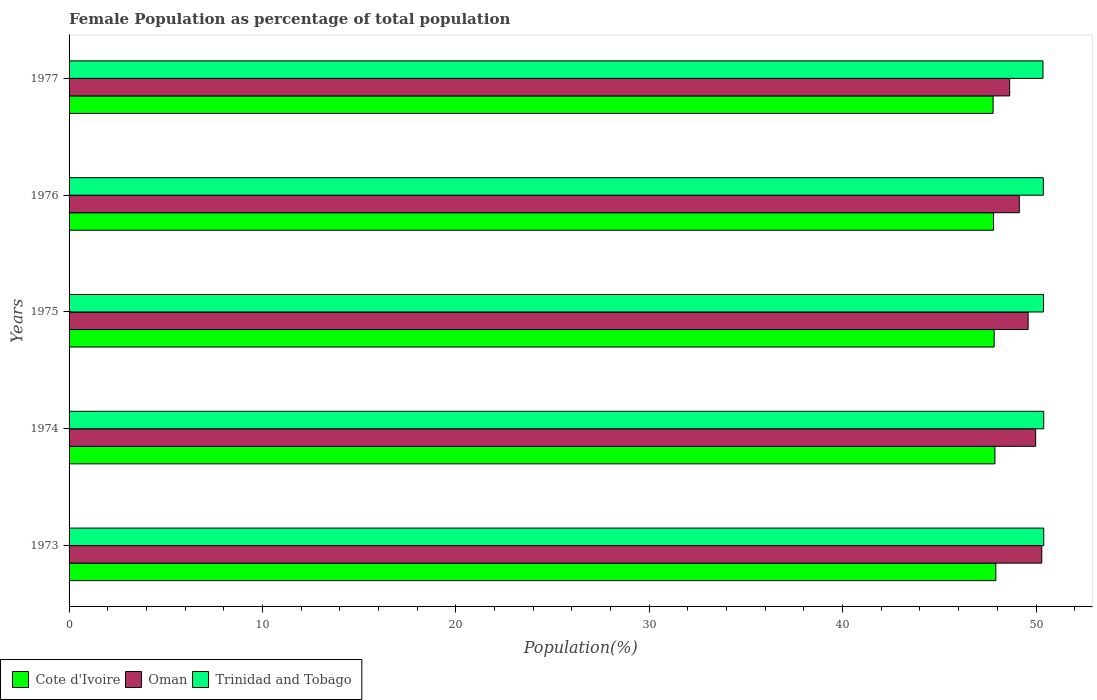How many groups of bars are there?
Offer a terse response. 5. How many bars are there on the 4th tick from the top?
Your response must be concise. 3. How many bars are there on the 2nd tick from the bottom?
Your answer should be very brief. 3. What is the label of the 2nd group of bars from the top?
Provide a succinct answer. 1976. What is the female population in in Trinidad and Tobago in 1975?
Give a very brief answer. 50.39. Across all years, what is the maximum female population in in Trinidad and Tobago?
Your answer should be compact. 50.4. Across all years, what is the minimum female population in in Cote d'Ivoire?
Your answer should be compact. 47.78. What is the total female population in in Trinidad and Tobago in the graph?
Ensure brevity in your answer.  251.93. What is the difference between the female population in in Trinidad and Tobago in 1974 and that in 1975?
Give a very brief answer. 0.01. What is the difference between the female population in in Trinidad and Tobago in 1977 and the female population in in Cote d'Ivoire in 1974?
Give a very brief answer. 2.48. What is the average female population in in Cote d'Ivoire per year?
Ensure brevity in your answer.  47.84. In the year 1974, what is the difference between the female population in in Trinidad and Tobago and female population in in Oman?
Your answer should be very brief. 0.42. In how many years, is the female population in in Oman greater than 10 %?
Keep it short and to the point. 5. What is the ratio of the female population in in Oman in 1974 to that in 1975?
Offer a very short reply. 1.01. Is the female population in in Cote d'Ivoire in 1973 less than that in 1974?
Offer a very short reply. No. What is the difference between the highest and the second highest female population in in Cote d'Ivoire?
Provide a short and direct response. 0.05. What is the difference between the highest and the lowest female population in in Oman?
Provide a short and direct response. 1.66. What does the 2nd bar from the top in 1974 represents?
Ensure brevity in your answer.  Oman. What does the 2nd bar from the bottom in 1976 represents?
Provide a succinct answer. Oman. Are all the bars in the graph horizontal?
Offer a terse response. Yes. Does the graph contain any zero values?
Ensure brevity in your answer.  No. How many legend labels are there?
Your response must be concise. 3. What is the title of the graph?
Ensure brevity in your answer.  Female Population as percentage of total population. What is the label or title of the X-axis?
Keep it short and to the point. Population(%). What is the label or title of the Y-axis?
Give a very brief answer. Years. What is the Population(%) in Cote d'Ivoire in 1973?
Make the answer very short. 47.92. What is the Population(%) in Oman in 1973?
Ensure brevity in your answer.  50.3. What is the Population(%) of Trinidad and Tobago in 1973?
Your answer should be compact. 50.4. What is the Population(%) of Cote d'Ivoire in 1974?
Provide a short and direct response. 47.88. What is the Population(%) of Oman in 1974?
Your answer should be very brief. 49.98. What is the Population(%) of Trinidad and Tobago in 1974?
Your answer should be very brief. 50.4. What is the Population(%) of Cote d'Ivoire in 1975?
Your answer should be compact. 47.84. What is the Population(%) in Oman in 1975?
Make the answer very short. 49.59. What is the Population(%) in Trinidad and Tobago in 1975?
Ensure brevity in your answer.  50.39. What is the Population(%) of Cote d'Ivoire in 1976?
Offer a very short reply. 47.81. What is the Population(%) of Oman in 1976?
Offer a very short reply. 49.14. What is the Population(%) of Trinidad and Tobago in 1976?
Provide a succinct answer. 50.38. What is the Population(%) in Cote d'Ivoire in 1977?
Offer a terse response. 47.78. What is the Population(%) of Oman in 1977?
Keep it short and to the point. 48.64. What is the Population(%) in Trinidad and Tobago in 1977?
Ensure brevity in your answer.  50.36. Across all years, what is the maximum Population(%) in Cote d'Ivoire?
Give a very brief answer. 47.92. Across all years, what is the maximum Population(%) in Oman?
Provide a succinct answer. 50.3. Across all years, what is the maximum Population(%) in Trinidad and Tobago?
Your response must be concise. 50.4. Across all years, what is the minimum Population(%) in Cote d'Ivoire?
Offer a very short reply. 47.78. Across all years, what is the minimum Population(%) in Oman?
Give a very brief answer. 48.64. Across all years, what is the minimum Population(%) in Trinidad and Tobago?
Your response must be concise. 50.36. What is the total Population(%) of Cote d'Ivoire in the graph?
Offer a very short reply. 239.22. What is the total Population(%) in Oman in the graph?
Ensure brevity in your answer.  247.65. What is the total Population(%) of Trinidad and Tobago in the graph?
Give a very brief answer. 251.93. What is the difference between the Population(%) of Cote d'Ivoire in 1973 and that in 1974?
Your answer should be very brief. 0.05. What is the difference between the Population(%) in Oman in 1973 and that in 1974?
Offer a terse response. 0.32. What is the difference between the Population(%) in Trinidad and Tobago in 1973 and that in 1974?
Offer a terse response. 0. What is the difference between the Population(%) in Cote d'Ivoire in 1973 and that in 1975?
Keep it short and to the point. 0.09. What is the difference between the Population(%) in Oman in 1973 and that in 1975?
Ensure brevity in your answer.  0.71. What is the difference between the Population(%) of Trinidad and Tobago in 1973 and that in 1975?
Ensure brevity in your answer.  0.01. What is the difference between the Population(%) in Cote d'Ivoire in 1973 and that in 1976?
Provide a succinct answer. 0.12. What is the difference between the Population(%) of Oman in 1973 and that in 1976?
Give a very brief answer. 1.16. What is the difference between the Population(%) in Trinidad and Tobago in 1973 and that in 1976?
Your answer should be very brief. 0.02. What is the difference between the Population(%) in Cote d'Ivoire in 1973 and that in 1977?
Offer a very short reply. 0.14. What is the difference between the Population(%) of Oman in 1973 and that in 1977?
Offer a very short reply. 1.66. What is the difference between the Population(%) in Trinidad and Tobago in 1973 and that in 1977?
Your answer should be compact. 0.04. What is the difference between the Population(%) of Cote d'Ivoire in 1974 and that in 1975?
Ensure brevity in your answer.  0.04. What is the difference between the Population(%) of Oman in 1974 and that in 1975?
Make the answer very short. 0.39. What is the difference between the Population(%) in Trinidad and Tobago in 1974 and that in 1975?
Ensure brevity in your answer.  0.01. What is the difference between the Population(%) of Cote d'Ivoire in 1974 and that in 1976?
Keep it short and to the point. 0.07. What is the difference between the Population(%) of Oman in 1974 and that in 1976?
Keep it short and to the point. 0.84. What is the difference between the Population(%) in Trinidad and Tobago in 1974 and that in 1976?
Offer a very short reply. 0.02. What is the difference between the Population(%) of Cote d'Ivoire in 1974 and that in 1977?
Offer a terse response. 0.1. What is the difference between the Population(%) in Oman in 1974 and that in 1977?
Your response must be concise. 1.34. What is the difference between the Population(%) in Trinidad and Tobago in 1974 and that in 1977?
Keep it short and to the point. 0.04. What is the difference between the Population(%) in Cote d'Ivoire in 1975 and that in 1976?
Offer a very short reply. 0.03. What is the difference between the Population(%) of Oman in 1975 and that in 1976?
Your answer should be very brief. 0.46. What is the difference between the Population(%) in Trinidad and Tobago in 1975 and that in 1976?
Ensure brevity in your answer.  0.01. What is the difference between the Population(%) in Cote d'Ivoire in 1975 and that in 1977?
Make the answer very short. 0.06. What is the difference between the Population(%) in Oman in 1975 and that in 1977?
Provide a short and direct response. 0.95. What is the difference between the Population(%) of Trinidad and Tobago in 1975 and that in 1977?
Your answer should be compact. 0.03. What is the difference between the Population(%) in Cote d'Ivoire in 1976 and that in 1977?
Make the answer very short. 0.02. What is the difference between the Population(%) in Oman in 1976 and that in 1977?
Provide a short and direct response. 0.5. What is the difference between the Population(%) of Trinidad and Tobago in 1976 and that in 1977?
Ensure brevity in your answer.  0.02. What is the difference between the Population(%) in Cote d'Ivoire in 1973 and the Population(%) in Oman in 1974?
Provide a short and direct response. -2.06. What is the difference between the Population(%) in Cote d'Ivoire in 1973 and the Population(%) in Trinidad and Tobago in 1974?
Offer a very short reply. -2.47. What is the difference between the Population(%) in Oman in 1973 and the Population(%) in Trinidad and Tobago in 1974?
Ensure brevity in your answer.  -0.1. What is the difference between the Population(%) in Cote d'Ivoire in 1973 and the Population(%) in Oman in 1975?
Make the answer very short. -1.67. What is the difference between the Population(%) in Cote d'Ivoire in 1973 and the Population(%) in Trinidad and Tobago in 1975?
Your answer should be compact. -2.47. What is the difference between the Population(%) in Oman in 1973 and the Population(%) in Trinidad and Tobago in 1975?
Make the answer very short. -0.09. What is the difference between the Population(%) of Cote d'Ivoire in 1973 and the Population(%) of Oman in 1976?
Give a very brief answer. -1.21. What is the difference between the Population(%) of Cote d'Ivoire in 1973 and the Population(%) of Trinidad and Tobago in 1976?
Provide a short and direct response. -2.45. What is the difference between the Population(%) in Oman in 1973 and the Population(%) in Trinidad and Tobago in 1976?
Your response must be concise. -0.08. What is the difference between the Population(%) in Cote d'Ivoire in 1973 and the Population(%) in Oman in 1977?
Offer a terse response. -0.71. What is the difference between the Population(%) in Cote d'Ivoire in 1973 and the Population(%) in Trinidad and Tobago in 1977?
Provide a short and direct response. -2.44. What is the difference between the Population(%) in Oman in 1973 and the Population(%) in Trinidad and Tobago in 1977?
Your response must be concise. -0.06. What is the difference between the Population(%) in Cote d'Ivoire in 1974 and the Population(%) in Oman in 1975?
Ensure brevity in your answer.  -1.72. What is the difference between the Population(%) in Cote d'Ivoire in 1974 and the Population(%) in Trinidad and Tobago in 1975?
Make the answer very short. -2.51. What is the difference between the Population(%) in Oman in 1974 and the Population(%) in Trinidad and Tobago in 1975?
Ensure brevity in your answer.  -0.41. What is the difference between the Population(%) in Cote d'Ivoire in 1974 and the Population(%) in Oman in 1976?
Offer a terse response. -1.26. What is the difference between the Population(%) of Cote d'Ivoire in 1974 and the Population(%) of Trinidad and Tobago in 1976?
Provide a succinct answer. -2.5. What is the difference between the Population(%) in Oman in 1974 and the Population(%) in Trinidad and Tobago in 1976?
Provide a short and direct response. -0.4. What is the difference between the Population(%) in Cote d'Ivoire in 1974 and the Population(%) in Oman in 1977?
Your response must be concise. -0.76. What is the difference between the Population(%) in Cote d'Ivoire in 1974 and the Population(%) in Trinidad and Tobago in 1977?
Offer a terse response. -2.48. What is the difference between the Population(%) of Oman in 1974 and the Population(%) of Trinidad and Tobago in 1977?
Provide a succinct answer. -0.38. What is the difference between the Population(%) of Cote d'Ivoire in 1975 and the Population(%) of Oman in 1976?
Keep it short and to the point. -1.3. What is the difference between the Population(%) of Cote d'Ivoire in 1975 and the Population(%) of Trinidad and Tobago in 1976?
Ensure brevity in your answer.  -2.54. What is the difference between the Population(%) in Oman in 1975 and the Population(%) in Trinidad and Tobago in 1976?
Make the answer very short. -0.79. What is the difference between the Population(%) of Cote d'Ivoire in 1975 and the Population(%) of Oman in 1977?
Provide a short and direct response. -0.8. What is the difference between the Population(%) in Cote d'Ivoire in 1975 and the Population(%) in Trinidad and Tobago in 1977?
Provide a succinct answer. -2.52. What is the difference between the Population(%) of Oman in 1975 and the Population(%) of Trinidad and Tobago in 1977?
Offer a very short reply. -0.77. What is the difference between the Population(%) of Cote d'Ivoire in 1976 and the Population(%) of Oman in 1977?
Provide a succinct answer. -0.83. What is the difference between the Population(%) of Cote d'Ivoire in 1976 and the Population(%) of Trinidad and Tobago in 1977?
Your answer should be compact. -2.55. What is the difference between the Population(%) in Oman in 1976 and the Population(%) in Trinidad and Tobago in 1977?
Offer a very short reply. -1.22. What is the average Population(%) of Cote d'Ivoire per year?
Ensure brevity in your answer.  47.84. What is the average Population(%) of Oman per year?
Provide a short and direct response. 49.53. What is the average Population(%) of Trinidad and Tobago per year?
Offer a terse response. 50.39. In the year 1973, what is the difference between the Population(%) of Cote d'Ivoire and Population(%) of Oman?
Make the answer very short. -2.38. In the year 1973, what is the difference between the Population(%) of Cote d'Ivoire and Population(%) of Trinidad and Tobago?
Your response must be concise. -2.48. In the year 1973, what is the difference between the Population(%) in Oman and Population(%) in Trinidad and Tobago?
Your response must be concise. -0.1. In the year 1974, what is the difference between the Population(%) in Cote d'Ivoire and Population(%) in Oman?
Ensure brevity in your answer.  -2.11. In the year 1974, what is the difference between the Population(%) of Cote d'Ivoire and Population(%) of Trinidad and Tobago?
Provide a short and direct response. -2.52. In the year 1974, what is the difference between the Population(%) in Oman and Population(%) in Trinidad and Tobago?
Keep it short and to the point. -0.42. In the year 1975, what is the difference between the Population(%) in Cote d'Ivoire and Population(%) in Oman?
Offer a terse response. -1.76. In the year 1975, what is the difference between the Population(%) of Cote d'Ivoire and Population(%) of Trinidad and Tobago?
Your answer should be compact. -2.55. In the year 1975, what is the difference between the Population(%) of Oman and Population(%) of Trinidad and Tobago?
Ensure brevity in your answer.  -0.8. In the year 1976, what is the difference between the Population(%) in Cote d'Ivoire and Population(%) in Oman?
Offer a very short reply. -1.33. In the year 1976, what is the difference between the Population(%) in Cote d'Ivoire and Population(%) in Trinidad and Tobago?
Offer a terse response. -2.57. In the year 1976, what is the difference between the Population(%) of Oman and Population(%) of Trinidad and Tobago?
Provide a succinct answer. -1.24. In the year 1977, what is the difference between the Population(%) of Cote d'Ivoire and Population(%) of Oman?
Give a very brief answer. -0.86. In the year 1977, what is the difference between the Population(%) of Cote d'Ivoire and Population(%) of Trinidad and Tobago?
Give a very brief answer. -2.58. In the year 1977, what is the difference between the Population(%) of Oman and Population(%) of Trinidad and Tobago?
Keep it short and to the point. -1.72. What is the ratio of the Population(%) in Cote d'Ivoire in 1973 to that in 1974?
Keep it short and to the point. 1. What is the ratio of the Population(%) in Oman in 1973 to that in 1974?
Your answer should be compact. 1.01. What is the ratio of the Population(%) in Trinidad and Tobago in 1973 to that in 1974?
Your answer should be very brief. 1. What is the ratio of the Population(%) in Cote d'Ivoire in 1973 to that in 1975?
Keep it short and to the point. 1. What is the ratio of the Population(%) of Oman in 1973 to that in 1975?
Your answer should be very brief. 1.01. What is the ratio of the Population(%) in Cote d'Ivoire in 1973 to that in 1976?
Your response must be concise. 1. What is the ratio of the Population(%) of Oman in 1973 to that in 1976?
Offer a very short reply. 1.02. What is the ratio of the Population(%) in Trinidad and Tobago in 1973 to that in 1976?
Your answer should be very brief. 1. What is the ratio of the Population(%) of Oman in 1973 to that in 1977?
Ensure brevity in your answer.  1.03. What is the ratio of the Population(%) in Cote d'Ivoire in 1974 to that in 1975?
Keep it short and to the point. 1. What is the ratio of the Population(%) of Cote d'Ivoire in 1974 to that in 1976?
Your answer should be very brief. 1. What is the ratio of the Population(%) in Oman in 1974 to that in 1976?
Offer a terse response. 1.02. What is the ratio of the Population(%) in Trinidad and Tobago in 1974 to that in 1976?
Your answer should be very brief. 1. What is the ratio of the Population(%) in Cote d'Ivoire in 1974 to that in 1977?
Your answer should be compact. 1. What is the ratio of the Population(%) of Oman in 1974 to that in 1977?
Your answer should be very brief. 1.03. What is the ratio of the Population(%) of Trinidad and Tobago in 1974 to that in 1977?
Your answer should be very brief. 1. What is the ratio of the Population(%) of Oman in 1975 to that in 1976?
Provide a succinct answer. 1.01. What is the ratio of the Population(%) in Trinidad and Tobago in 1975 to that in 1976?
Keep it short and to the point. 1. What is the ratio of the Population(%) in Cote d'Ivoire in 1975 to that in 1977?
Provide a short and direct response. 1. What is the ratio of the Population(%) in Oman in 1975 to that in 1977?
Provide a short and direct response. 1.02. What is the ratio of the Population(%) in Oman in 1976 to that in 1977?
Provide a succinct answer. 1.01. What is the ratio of the Population(%) of Trinidad and Tobago in 1976 to that in 1977?
Your answer should be very brief. 1. What is the difference between the highest and the second highest Population(%) in Cote d'Ivoire?
Your answer should be very brief. 0.05. What is the difference between the highest and the second highest Population(%) in Oman?
Provide a succinct answer. 0.32. What is the difference between the highest and the second highest Population(%) in Trinidad and Tobago?
Make the answer very short. 0. What is the difference between the highest and the lowest Population(%) of Cote d'Ivoire?
Provide a short and direct response. 0.14. What is the difference between the highest and the lowest Population(%) in Oman?
Ensure brevity in your answer.  1.66. What is the difference between the highest and the lowest Population(%) of Trinidad and Tobago?
Your answer should be very brief. 0.04. 